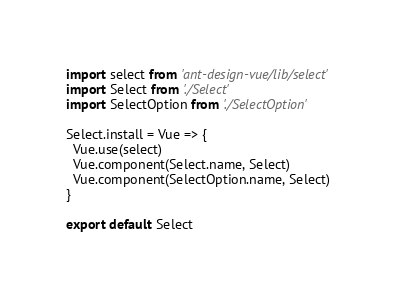<code> <loc_0><loc_0><loc_500><loc_500><_JavaScript_>import select from 'ant-design-vue/lib/select'
import Select from './Select'
import SelectOption from './SelectOption'

Select.install = Vue => {
  Vue.use(select)
  Vue.component(Select.name, Select)
  Vue.component(SelectOption.name, Select)
}

export default Select
</code> 